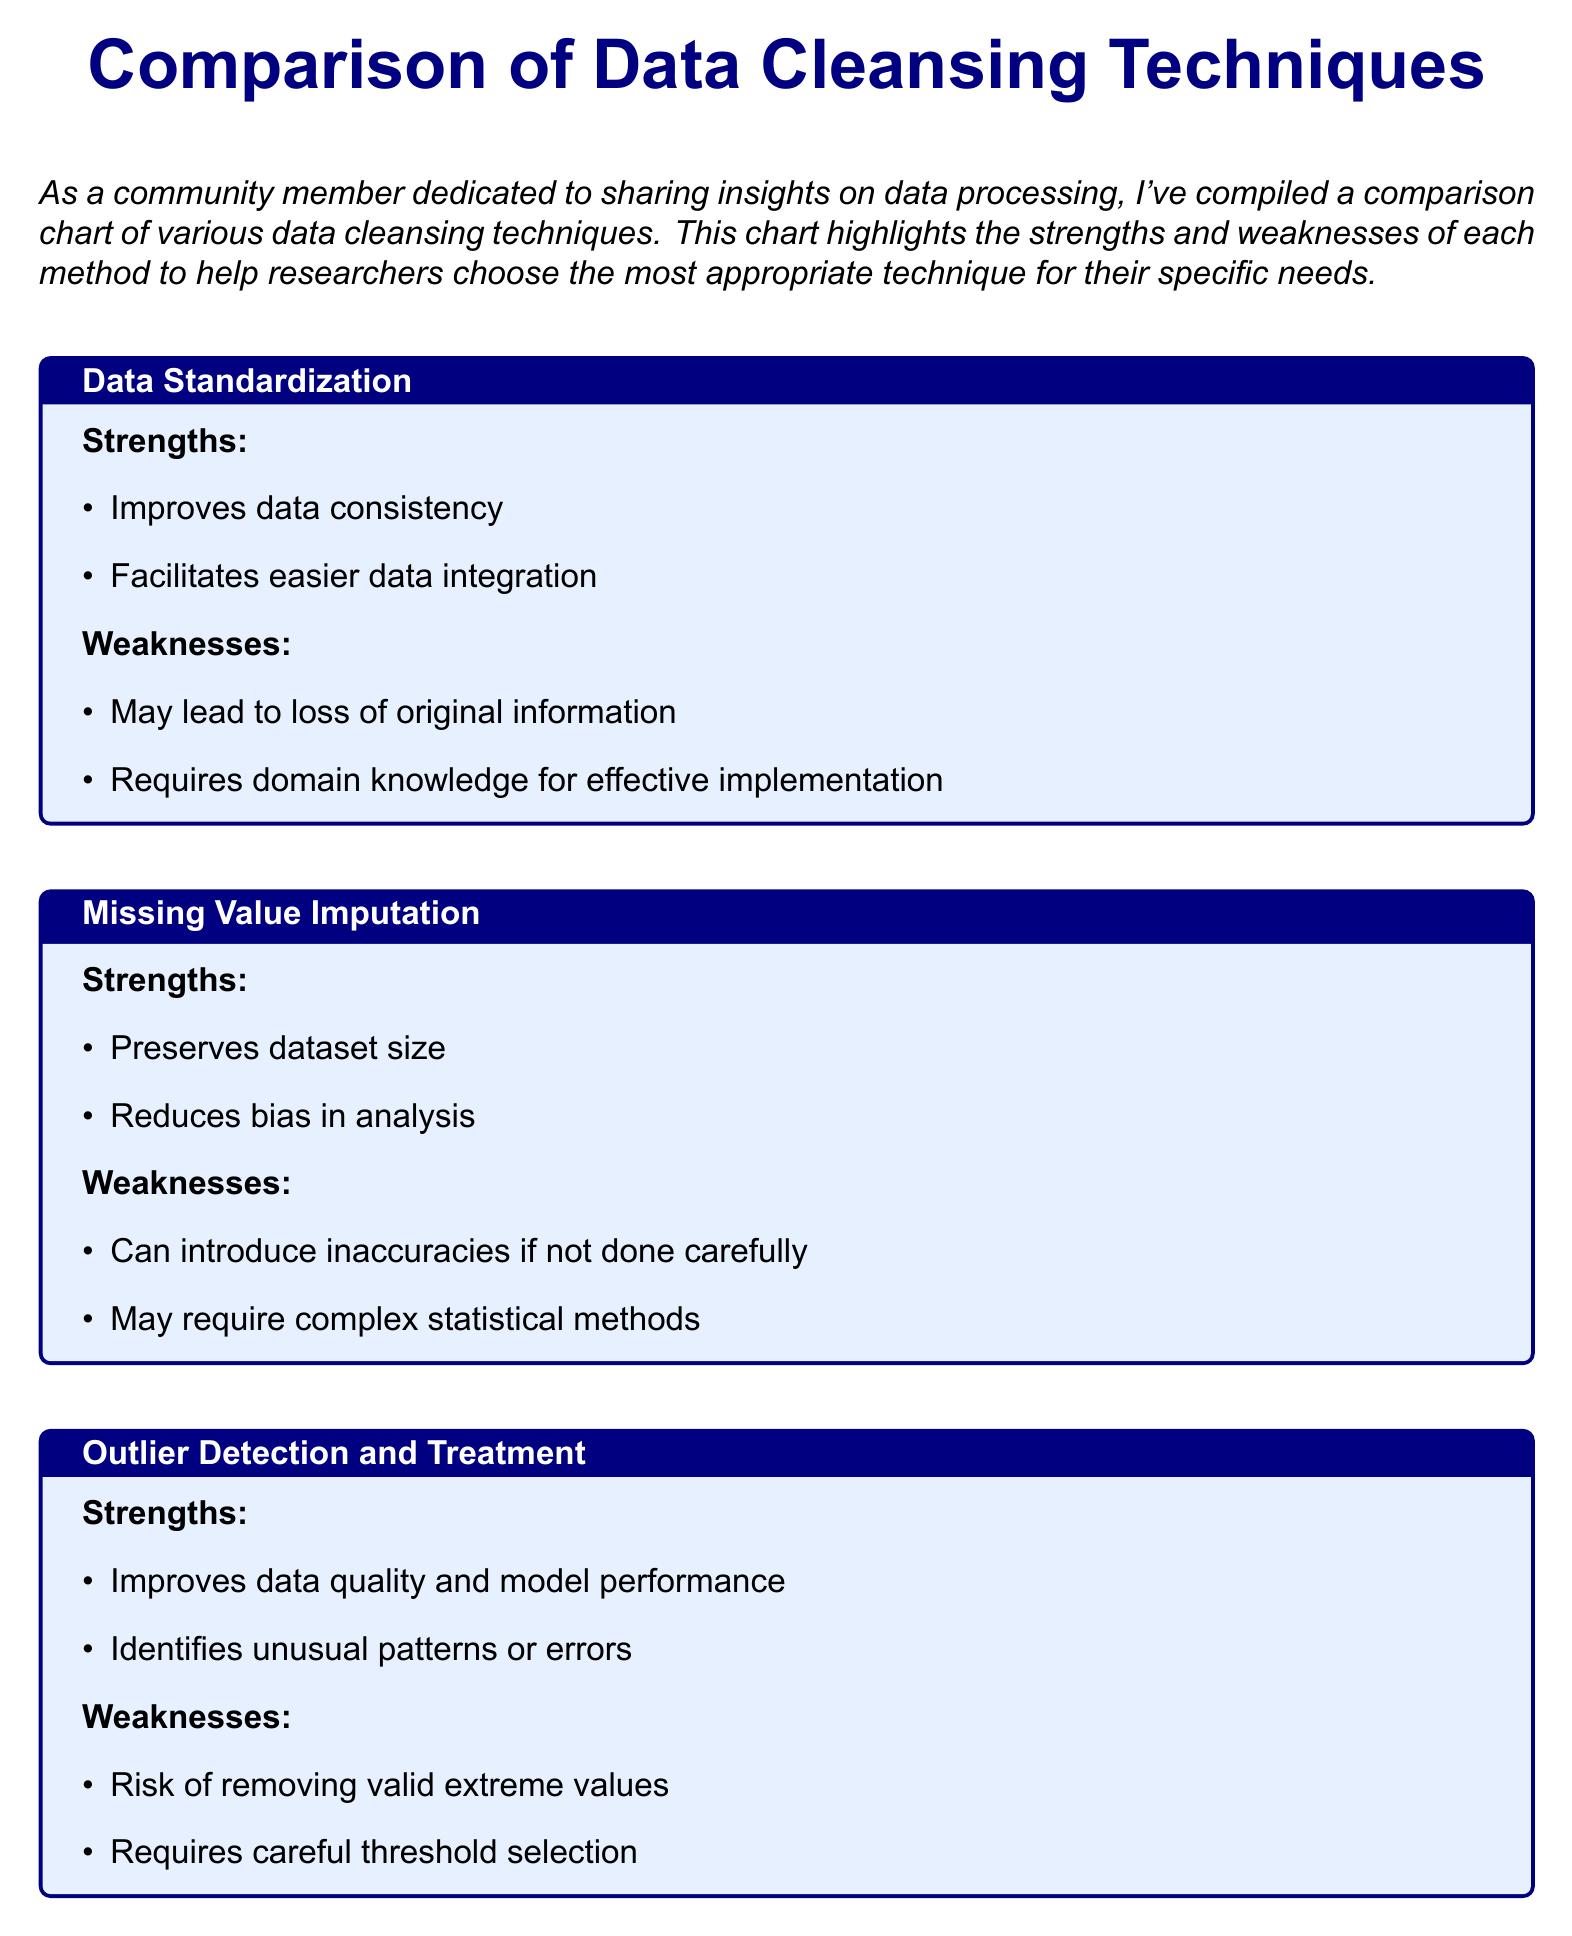What is the title of the document? The title of the document is prominently displayed at the top and clearly states what the document is about.
Answer: Comparison of Data Cleansing Techniques What is one strength of Data Standardization? The document lists strengths and weaknesses for each data cleansing technique, pointing out one of the benefits.
Answer: Improves data consistency What is one weakness of Missing Value Imputation? Each technique has drawbacks listed, and the document highlights a specific weakness for Missing Value Imputation.
Answer: Can introduce inaccuracies if not done carefully How does Deduplication affect storage? The strengths section of Deduplication discusses its impact on data storage as well as efficiency in managing data.
Answer: Improves storage efficiency What is a potential risk of Outlier Detection and Treatment? The weaknesses identified for Outlier Detection and Treatment highlight a specific risk involved in using this technique.
Answer: Risk of removing valid extreme values What technique can reduce bias in analysis? The strengths of Missing Value Imputation include its ability to maintain dataset size and improve analysis integrity.
Answer: Missing Value Imputation Which technique may require complex statistical methods? The weaknesses section of Missing Value Imputation specifies a necessary skill for effective application of this technique.
Answer: Missing Value Imputation What is the overall recommendation for using these techniques? The document concludes with insight recommending the combination of methods for the best outcomes based on specific scenarios.
Answer: Combine multiple techniques for optimal results 